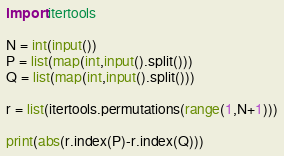<code> <loc_0><loc_0><loc_500><loc_500><_Python_>import itertools

N = int(input())
P = list(map(int,input().split()))
Q = list(map(int,input().split()))

r = list(itertools.permutations(range(1,N+1)))

print(abs(r.index(P)-r.index(Q)))</code> 